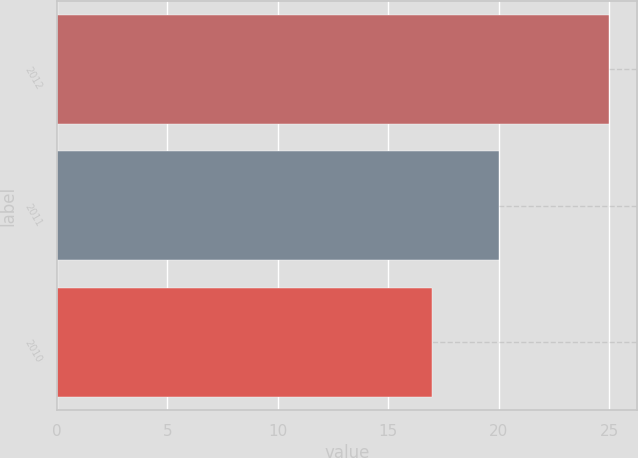Convert chart. <chart><loc_0><loc_0><loc_500><loc_500><bar_chart><fcel>2012<fcel>2011<fcel>2010<nl><fcel>25<fcel>20<fcel>17<nl></chart> 